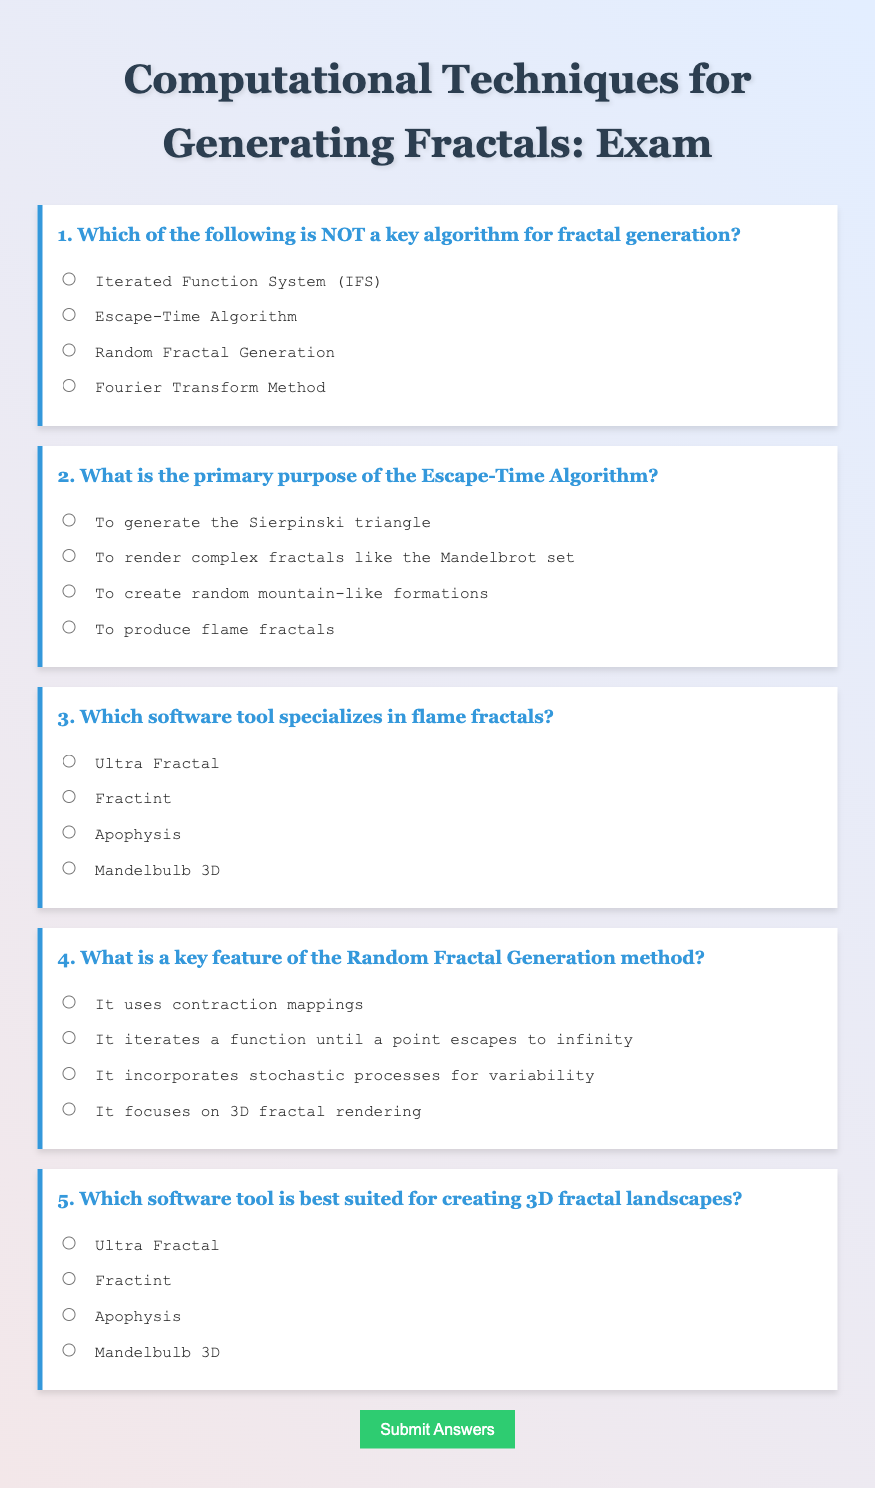What is the title of the exam? The title of the exam is presented at the top of the document in a centered format.
Answer: Computational Techniques for Generating Fractals: Exam How many questions are included in the exam? The document contains a total of five questions, each labeled numerically.
Answer: 5 Which algorithm is NOT listed as a key algorithm for fractal generation? The algorithms listed are presented in the options of the first question, which includes one that is not a fractal generation algorithm.
Answer: Fourier Transform Method What is the primary purpose of the Escape-Time Algorithm? The second question specifies the function of the Escape-Time Algorithm in one of its options.
Answer: To render complex fractals like the Mandelbrot set Which software tool is mentioned for creating flame fractals? This information is found in the options for the third question regarding software tools for specific fractals.
Answer: Apophysis What is a key feature of the Random Fractal Generation method? The fourth question highlights one distinguishing characteristic of the Random Fractal Generation method.
Answer: It incorporates stochastic processes for variability Which tool is best suited for 3D fractal landscapes? The best tool for creating 3D fractal landscapes is specified in the options for the fifth question.
Answer: Mandelbulb 3D 